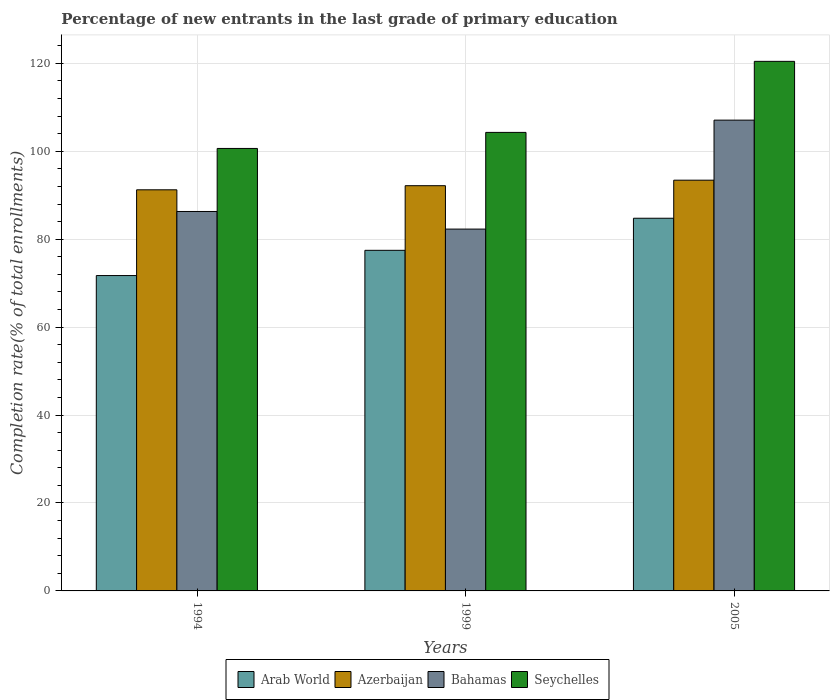How many groups of bars are there?
Provide a short and direct response. 3. Are the number of bars on each tick of the X-axis equal?
Your answer should be very brief. Yes. What is the percentage of new entrants in Azerbaijan in 1994?
Your response must be concise. 91.24. Across all years, what is the maximum percentage of new entrants in Bahamas?
Make the answer very short. 107.09. Across all years, what is the minimum percentage of new entrants in Azerbaijan?
Make the answer very short. 91.24. In which year was the percentage of new entrants in Seychelles minimum?
Ensure brevity in your answer.  1994. What is the total percentage of new entrants in Bahamas in the graph?
Your answer should be compact. 275.7. What is the difference between the percentage of new entrants in Arab World in 1994 and that in 1999?
Offer a very short reply. -5.74. What is the difference between the percentage of new entrants in Bahamas in 2005 and the percentage of new entrants in Azerbaijan in 1999?
Provide a succinct answer. 14.91. What is the average percentage of new entrants in Azerbaijan per year?
Make the answer very short. 92.28. In the year 2005, what is the difference between the percentage of new entrants in Arab World and percentage of new entrants in Seychelles?
Offer a terse response. -35.69. What is the ratio of the percentage of new entrants in Seychelles in 1999 to that in 2005?
Your response must be concise. 0.87. Is the difference between the percentage of new entrants in Arab World in 1994 and 2005 greater than the difference between the percentage of new entrants in Seychelles in 1994 and 2005?
Your answer should be compact. Yes. What is the difference between the highest and the second highest percentage of new entrants in Seychelles?
Give a very brief answer. 16.16. What is the difference between the highest and the lowest percentage of new entrants in Arab World?
Your answer should be very brief. 13.04. In how many years, is the percentage of new entrants in Arab World greater than the average percentage of new entrants in Arab World taken over all years?
Your answer should be very brief. 1. Is the sum of the percentage of new entrants in Arab World in 1994 and 1999 greater than the maximum percentage of new entrants in Seychelles across all years?
Give a very brief answer. Yes. Is it the case that in every year, the sum of the percentage of new entrants in Azerbaijan and percentage of new entrants in Arab World is greater than the sum of percentage of new entrants in Bahamas and percentage of new entrants in Seychelles?
Your response must be concise. No. What does the 3rd bar from the left in 1999 represents?
Give a very brief answer. Bahamas. What does the 3rd bar from the right in 1994 represents?
Provide a short and direct response. Azerbaijan. How many years are there in the graph?
Your response must be concise. 3. What is the difference between two consecutive major ticks on the Y-axis?
Give a very brief answer. 20. Does the graph contain any zero values?
Keep it short and to the point. No. Does the graph contain grids?
Make the answer very short. Yes. How many legend labels are there?
Provide a succinct answer. 4. What is the title of the graph?
Make the answer very short. Percentage of new entrants in the last grade of primary education. What is the label or title of the X-axis?
Ensure brevity in your answer.  Years. What is the label or title of the Y-axis?
Provide a succinct answer. Completion rate(% of total enrollments). What is the Completion rate(% of total enrollments) of Arab World in 1994?
Keep it short and to the point. 71.74. What is the Completion rate(% of total enrollments) of Azerbaijan in 1994?
Your response must be concise. 91.24. What is the Completion rate(% of total enrollments) of Bahamas in 1994?
Provide a succinct answer. 86.31. What is the Completion rate(% of total enrollments) in Seychelles in 1994?
Your answer should be very brief. 100.65. What is the Completion rate(% of total enrollments) in Arab World in 1999?
Keep it short and to the point. 77.47. What is the Completion rate(% of total enrollments) in Azerbaijan in 1999?
Keep it short and to the point. 92.17. What is the Completion rate(% of total enrollments) of Bahamas in 1999?
Make the answer very short. 82.3. What is the Completion rate(% of total enrollments) in Seychelles in 1999?
Keep it short and to the point. 104.3. What is the Completion rate(% of total enrollments) of Arab World in 2005?
Offer a terse response. 84.77. What is the Completion rate(% of total enrollments) of Azerbaijan in 2005?
Ensure brevity in your answer.  93.43. What is the Completion rate(% of total enrollments) of Bahamas in 2005?
Provide a succinct answer. 107.09. What is the Completion rate(% of total enrollments) of Seychelles in 2005?
Make the answer very short. 120.46. Across all years, what is the maximum Completion rate(% of total enrollments) of Arab World?
Keep it short and to the point. 84.77. Across all years, what is the maximum Completion rate(% of total enrollments) in Azerbaijan?
Offer a very short reply. 93.43. Across all years, what is the maximum Completion rate(% of total enrollments) in Bahamas?
Offer a terse response. 107.09. Across all years, what is the maximum Completion rate(% of total enrollments) of Seychelles?
Provide a short and direct response. 120.46. Across all years, what is the minimum Completion rate(% of total enrollments) in Arab World?
Make the answer very short. 71.74. Across all years, what is the minimum Completion rate(% of total enrollments) of Azerbaijan?
Make the answer very short. 91.24. Across all years, what is the minimum Completion rate(% of total enrollments) in Bahamas?
Offer a terse response. 82.3. Across all years, what is the minimum Completion rate(% of total enrollments) in Seychelles?
Offer a very short reply. 100.65. What is the total Completion rate(% of total enrollments) of Arab World in the graph?
Your response must be concise. 233.98. What is the total Completion rate(% of total enrollments) of Azerbaijan in the graph?
Offer a terse response. 276.84. What is the total Completion rate(% of total enrollments) in Bahamas in the graph?
Offer a terse response. 275.7. What is the total Completion rate(% of total enrollments) in Seychelles in the graph?
Ensure brevity in your answer.  325.4. What is the difference between the Completion rate(% of total enrollments) in Arab World in 1994 and that in 1999?
Offer a terse response. -5.74. What is the difference between the Completion rate(% of total enrollments) of Azerbaijan in 1994 and that in 1999?
Ensure brevity in your answer.  -0.93. What is the difference between the Completion rate(% of total enrollments) in Bahamas in 1994 and that in 1999?
Your answer should be very brief. 4.01. What is the difference between the Completion rate(% of total enrollments) in Seychelles in 1994 and that in 1999?
Offer a terse response. -3.65. What is the difference between the Completion rate(% of total enrollments) of Arab World in 1994 and that in 2005?
Keep it short and to the point. -13.04. What is the difference between the Completion rate(% of total enrollments) in Azerbaijan in 1994 and that in 2005?
Offer a terse response. -2.19. What is the difference between the Completion rate(% of total enrollments) of Bahamas in 1994 and that in 2005?
Your response must be concise. -20.78. What is the difference between the Completion rate(% of total enrollments) of Seychelles in 1994 and that in 2005?
Give a very brief answer. -19.81. What is the difference between the Completion rate(% of total enrollments) in Arab World in 1999 and that in 2005?
Give a very brief answer. -7.3. What is the difference between the Completion rate(% of total enrollments) of Azerbaijan in 1999 and that in 2005?
Ensure brevity in your answer.  -1.26. What is the difference between the Completion rate(% of total enrollments) of Bahamas in 1999 and that in 2005?
Your response must be concise. -24.78. What is the difference between the Completion rate(% of total enrollments) of Seychelles in 1999 and that in 2005?
Offer a very short reply. -16.16. What is the difference between the Completion rate(% of total enrollments) in Arab World in 1994 and the Completion rate(% of total enrollments) in Azerbaijan in 1999?
Give a very brief answer. -20.44. What is the difference between the Completion rate(% of total enrollments) in Arab World in 1994 and the Completion rate(% of total enrollments) in Bahamas in 1999?
Provide a short and direct response. -10.57. What is the difference between the Completion rate(% of total enrollments) of Arab World in 1994 and the Completion rate(% of total enrollments) of Seychelles in 1999?
Provide a succinct answer. -32.56. What is the difference between the Completion rate(% of total enrollments) of Azerbaijan in 1994 and the Completion rate(% of total enrollments) of Bahamas in 1999?
Offer a terse response. 8.93. What is the difference between the Completion rate(% of total enrollments) in Azerbaijan in 1994 and the Completion rate(% of total enrollments) in Seychelles in 1999?
Give a very brief answer. -13.06. What is the difference between the Completion rate(% of total enrollments) of Bahamas in 1994 and the Completion rate(% of total enrollments) of Seychelles in 1999?
Ensure brevity in your answer.  -17.99. What is the difference between the Completion rate(% of total enrollments) in Arab World in 1994 and the Completion rate(% of total enrollments) in Azerbaijan in 2005?
Give a very brief answer. -21.7. What is the difference between the Completion rate(% of total enrollments) of Arab World in 1994 and the Completion rate(% of total enrollments) of Bahamas in 2005?
Provide a short and direct response. -35.35. What is the difference between the Completion rate(% of total enrollments) of Arab World in 1994 and the Completion rate(% of total enrollments) of Seychelles in 2005?
Give a very brief answer. -48.72. What is the difference between the Completion rate(% of total enrollments) in Azerbaijan in 1994 and the Completion rate(% of total enrollments) in Bahamas in 2005?
Provide a short and direct response. -15.85. What is the difference between the Completion rate(% of total enrollments) in Azerbaijan in 1994 and the Completion rate(% of total enrollments) in Seychelles in 2005?
Make the answer very short. -29.22. What is the difference between the Completion rate(% of total enrollments) of Bahamas in 1994 and the Completion rate(% of total enrollments) of Seychelles in 2005?
Your answer should be compact. -34.15. What is the difference between the Completion rate(% of total enrollments) of Arab World in 1999 and the Completion rate(% of total enrollments) of Azerbaijan in 2005?
Keep it short and to the point. -15.96. What is the difference between the Completion rate(% of total enrollments) in Arab World in 1999 and the Completion rate(% of total enrollments) in Bahamas in 2005?
Offer a terse response. -29.61. What is the difference between the Completion rate(% of total enrollments) of Arab World in 1999 and the Completion rate(% of total enrollments) of Seychelles in 2005?
Offer a terse response. -42.98. What is the difference between the Completion rate(% of total enrollments) of Azerbaijan in 1999 and the Completion rate(% of total enrollments) of Bahamas in 2005?
Offer a terse response. -14.91. What is the difference between the Completion rate(% of total enrollments) of Azerbaijan in 1999 and the Completion rate(% of total enrollments) of Seychelles in 2005?
Offer a very short reply. -28.28. What is the difference between the Completion rate(% of total enrollments) in Bahamas in 1999 and the Completion rate(% of total enrollments) in Seychelles in 2005?
Provide a succinct answer. -38.15. What is the average Completion rate(% of total enrollments) of Arab World per year?
Give a very brief answer. 77.99. What is the average Completion rate(% of total enrollments) of Azerbaijan per year?
Your answer should be compact. 92.28. What is the average Completion rate(% of total enrollments) of Bahamas per year?
Your response must be concise. 91.9. What is the average Completion rate(% of total enrollments) in Seychelles per year?
Ensure brevity in your answer.  108.47. In the year 1994, what is the difference between the Completion rate(% of total enrollments) of Arab World and Completion rate(% of total enrollments) of Azerbaijan?
Give a very brief answer. -19.5. In the year 1994, what is the difference between the Completion rate(% of total enrollments) of Arab World and Completion rate(% of total enrollments) of Bahamas?
Make the answer very short. -14.58. In the year 1994, what is the difference between the Completion rate(% of total enrollments) in Arab World and Completion rate(% of total enrollments) in Seychelles?
Offer a very short reply. -28.91. In the year 1994, what is the difference between the Completion rate(% of total enrollments) of Azerbaijan and Completion rate(% of total enrollments) of Bahamas?
Provide a succinct answer. 4.93. In the year 1994, what is the difference between the Completion rate(% of total enrollments) of Azerbaijan and Completion rate(% of total enrollments) of Seychelles?
Give a very brief answer. -9.41. In the year 1994, what is the difference between the Completion rate(% of total enrollments) of Bahamas and Completion rate(% of total enrollments) of Seychelles?
Your answer should be very brief. -14.34. In the year 1999, what is the difference between the Completion rate(% of total enrollments) of Arab World and Completion rate(% of total enrollments) of Azerbaijan?
Keep it short and to the point. -14.7. In the year 1999, what is the difference between the Completion rate(% of total enrollments) of Arab World and Completion rate(% of total enrollments) of Bahamas?
Offer a terse response. -4.83. In the year 1999, what is the difference between the Completion rate(% of total enrollments) of Arab World and Completion rate(% of total enrollments) of Seychelles?
Provide a short and direct response. -26.82. In the year 1999, what is the difference between the Completion rate(% of total enrollments) of Azerbaijan and Completion rate(% of total enrollments) of Bahamas?
Offer a very short reply. 9.87. In the year 1999, what is the difference between the Completion rate(% of total enrollments) of Azerbaijan and Completion rate(% of total enrollments) of Seychelles?
Provide a short and direct response. -12.12. In the year 1999, what is the difference between the Completion rate(% of total enrollments) in Bahamas and Completion rate(% of total enrollments) in Seychelles?
Provide a short and direct response. -21.99. In the year 2005, what is the difference between the Completion rate(% of total enrollments) of Arab World and Completion rate(% of total enrollments) of Azerbaijan?
Provide a succinct answer. -8.66. In the year 2005, what is the difference between the Completion rate(% of total enrollments) of Arab World and Completion rate(% of total enrollments) of Bahamas?
Keep it short and to the point. -22.32. In the year 2005, what is the difference between the Completion rate(% of total enrollments) of Arab World and Completion rate(% of total enrollments) of Seychelles?
Offer a terse response. -35.69. In the year 2005, what is the difference between the Completion rate(% of total enrollments) of Azerbaijan and Completion rate(% of total enrollments) of Bahamas?
Give a very brief answer. -13.66. In the year 2005, what is the difference between the Completion rate(% of total enrollments) of Azerbaijan and Completion rate(% of total enrollments) of Seychelles?
Offer a very short reply. -27.03. In the year 2005, what is the difference between the Completion rate(% of total enrollments) of Bahamas and Completion rate(% of total enrollments) of Seychelles?
Offer a terse response. -13.37. What is the ratio of the Completion rate(% of total enrollments) in Arab World in 1994 to that in 1999?
Ensure brevity in your answer.  0.93. What is the ratio of the Completion rate(% of total enrollments) of Bahamas in 1994 to that in 1999?
Provide a succinct answer. 1.05. What is the ratio of the Completion rate(% of total enrollments) in Arab World in 1994 to that in 2005?
Offer a very short reply. 0.85. What is the ratio of the Completion rate(% of total enrollments) in Azerbaijan in 1994 to that in 2005?
Ensure brevity in your answer.  0.98. What is the ratio of the Completion rate(% of total enrollments) of Bahamas in 1994 to that in 2005?
Make the answer very short. 0.81. What is the ratio of the Completion rate(% of total enrollments) in Seychelles in 1994 to that in 2005?
Make the answer very short. 0.84. What is the ratio of the Completion rate(% of total enrollments) of Arab World in 1999 to that in 2005?
Make the answer very short. 0.91. What is the ratio of the Completion rate(% of total enrollments) in Azerbaijan in 1999 to that in 2005?
Ensure brevity in your answer.  0.99. What is the ratio of the Completion rate(% of total enrollments) in Bahamas in 1999 to that in 2005?
Give a very brief answer. 0.77. What is the ratio of the Completion rate(% of total enrollments) of Seychelles in 1999 to that in 2005?
Your answer should be very brief. 0.87. What is the difference between the highest and the second highest Completion rate(% of total enrollments) in Arab World?
Provide a short and direct response. 7.3. What is the difference between the highest and the second highest Completion rate(% of total enrollments) of Azerbaijan?
Make the answer very short. 1.26. What is the difference between the highest and the second highest Completion rate(% of total enrollments) in Bahamas?
Make the answer very short. 20.78. What is the difference between the highest and the second highest Completion rate(% of total enrollments) in Seychelles?
Your answer should be very brief. 16.16. What is the difference between the highest and the lowest Completion rate(% of total enrollments) in Arab World?
Offer a terse response. 13.04. What is the difference between the highest and the lowest Completion rate(% of total enrollments) in Azerbaijan?
Ensure brevity in your answer.  2.19. What is the difference between the highest and the lowest Completion rate(% of total enrollments) in Bahamas?
Keep it short and to the point. 24.78. What is the difference between the highest and the lowest Completion rate(% of total enrollments) of Seychelles?
Ensure brevity in your answer.  19.81. 